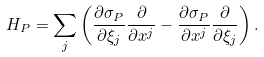Convert formula to latex. <formula><loc_0><loc_0><loc_500><loc_500>H _ { P } = \sum _ { j } \left ( \frac { \partial \sigma _ { P } } { \partial \xi _ { j } } \frac { \partial } { \partial x ^ { j } } - \frac { \partial \sigma _ { P } } { \partial x ^ { j } } \frac { \partial } { \partial \xi _ { j } } \right ) .</formula> 